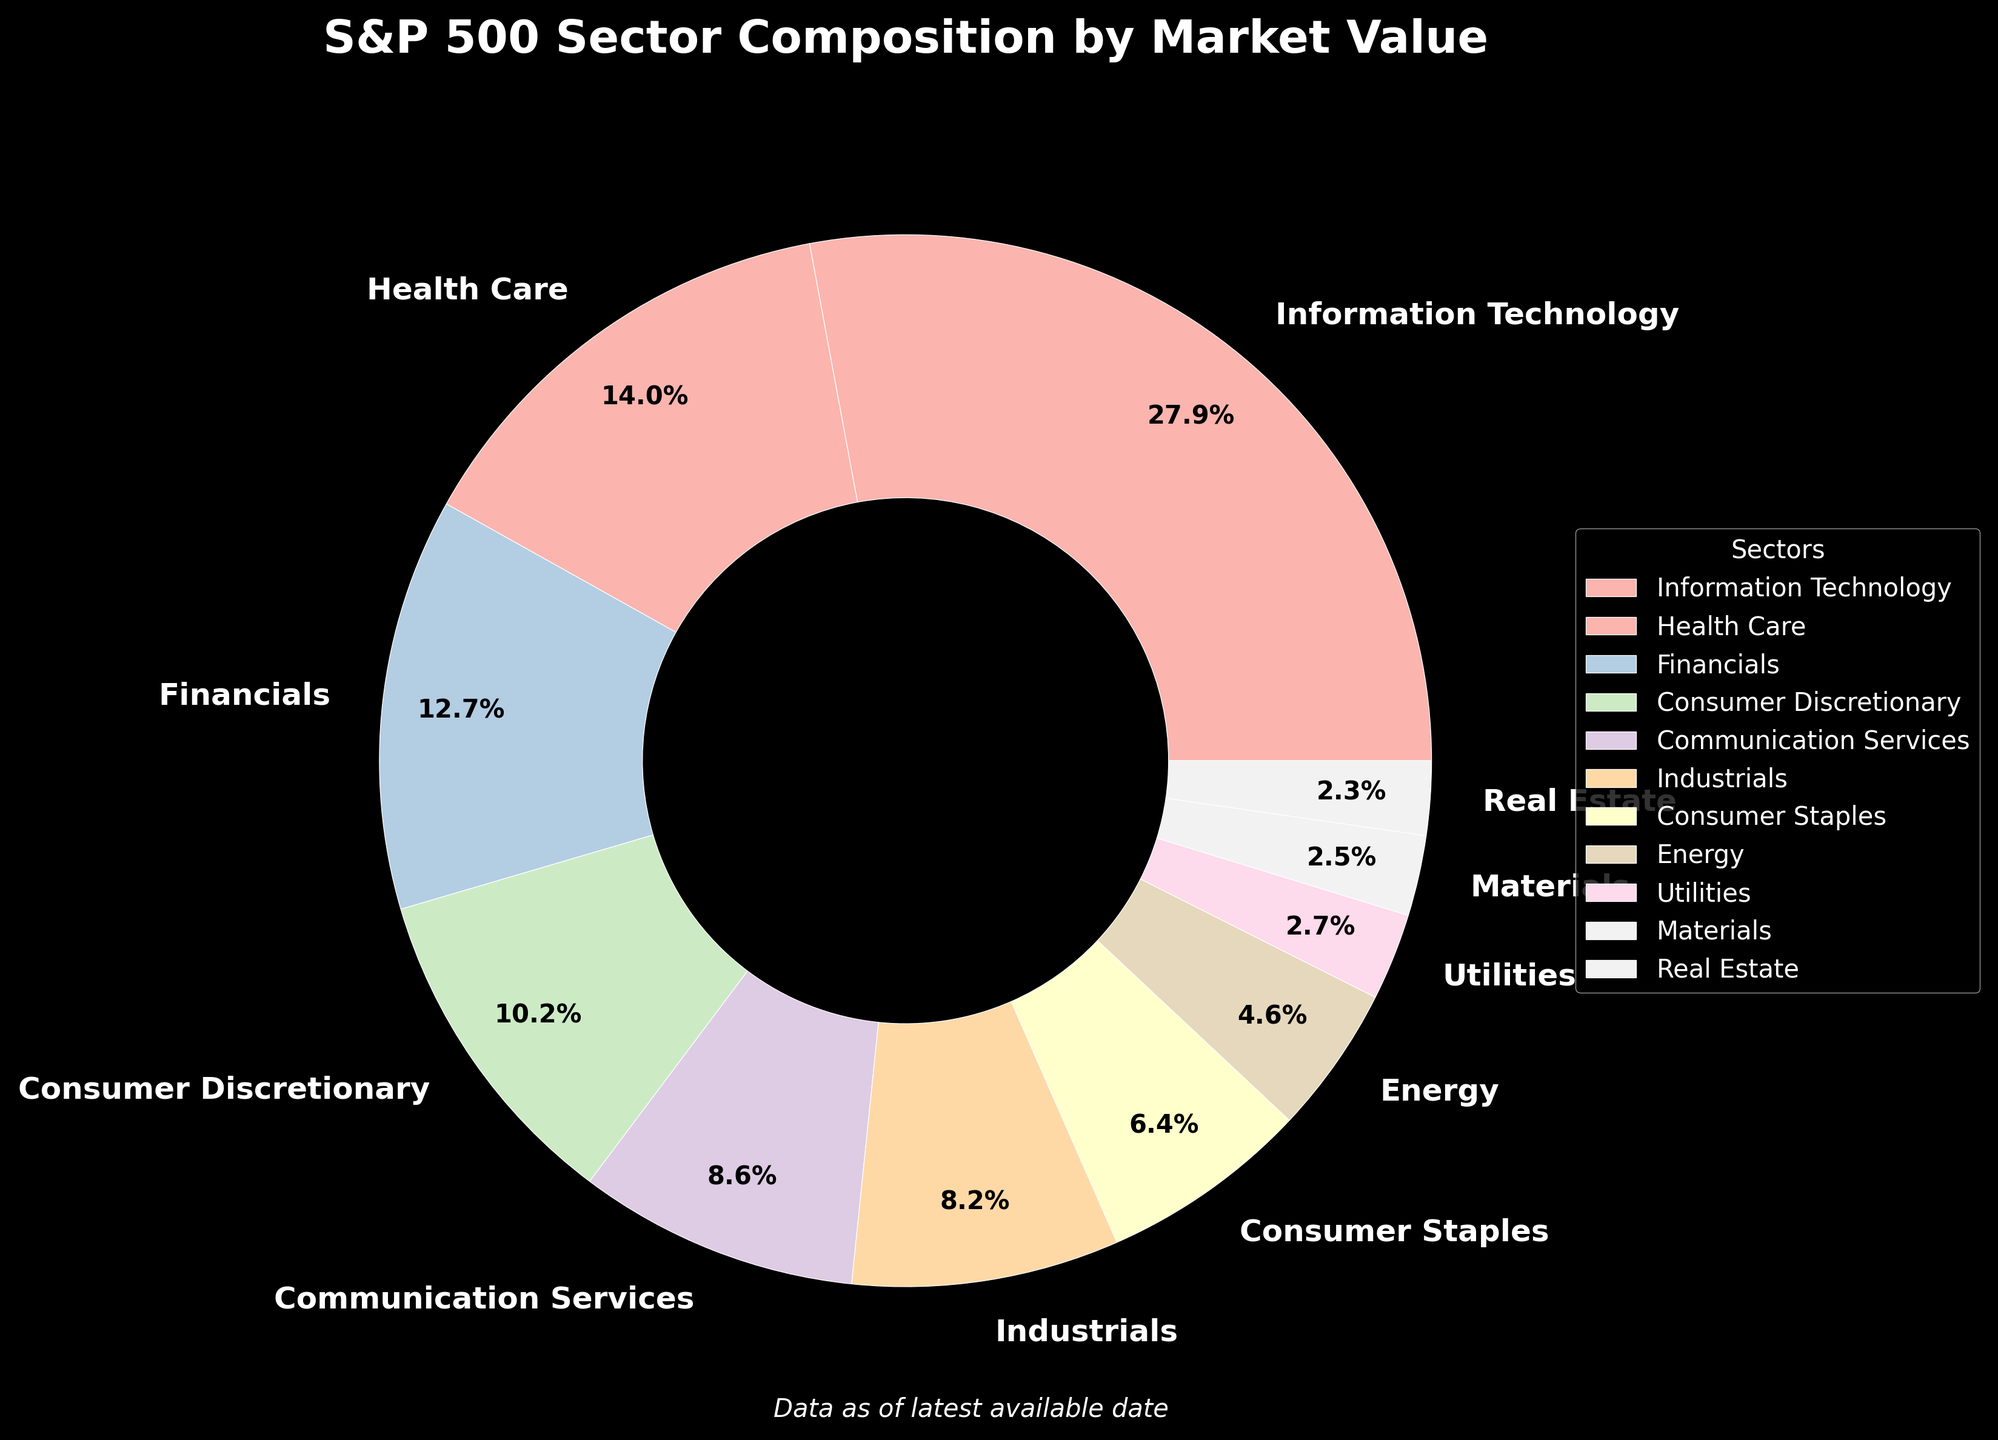What is the total market value percentage for sectors contributing less than 5% each? Sectors contributing less than 5% are Energy (4.6%), Utilities (2.7%), Materials (2.5%), and Real Estate (2.3%). Summing these values: 4.6 + 2.7 + 2.5 + 2.3 = 12.1%
Answer: 12.1% Which sector has the highest market value percentage? The sector with the highest market value percentage can be determined by comparing the values. Information Technology has the highest at 28.2%.
Answer: Information Technology Compare the total market value percentage of Health Care and Financials sectors. Health Care has 14.1% and Financials has 12.8%. Adding these: 14.1 + 12.8 = 26.9%
Answer: 26.9% What is the difference in market value percentage between Consumer Discretionary and Consumer Staples? Consumer Discretionary has 10.3% and Consumer Staples has 6.5%. Subtraction gives: 10.3 - 6.5 = 3.8%
Answer: 3.8% How much larger is the market value percentage of Health Care compared to Communication Services? Health Care has 14.1% and Communication Services has 8.7%. The difference is: 14.1 - 8.7 = 5.4%
Answer: 5.4% Which sectors have market value percentages within the range of 8% to 15%? The sectors within this range are Health Care (14.1%), Financials (12.8%), Consumer Discretionary (10.3%), Communication Services (8.7%), and Industrials (8.3%).
Answer: Health Care, Financials, Consumer Discretionary, Communication Services, Industrials Identify the second smallest and second largest sectors by market value percentage. Sorting the sectors by market value percentage, second smallest is Real Estate (2.3%) and second largest is Health Care (14.1%).
Answer: Real Estate, Health Care What is the average market value percentage of the Industrials, Consumer Staples, and Energy sectors? Adding the percentages: 8.3 + 6.5 + 4.6 = 19.4%. Dividing by the number of sectors: 19.4 / 3 = 6.47%.
Answer: 6.47% By how much does the market value percentage of the Information Technology sector exceed the combined value of Utilities and Materials? Information Technology is 28.2%, Utilities and Materials together are 2.7% + 2.5% = 5.2%. The difference is: 28.2 - 5.2 = 23%.
Answer: 23% 